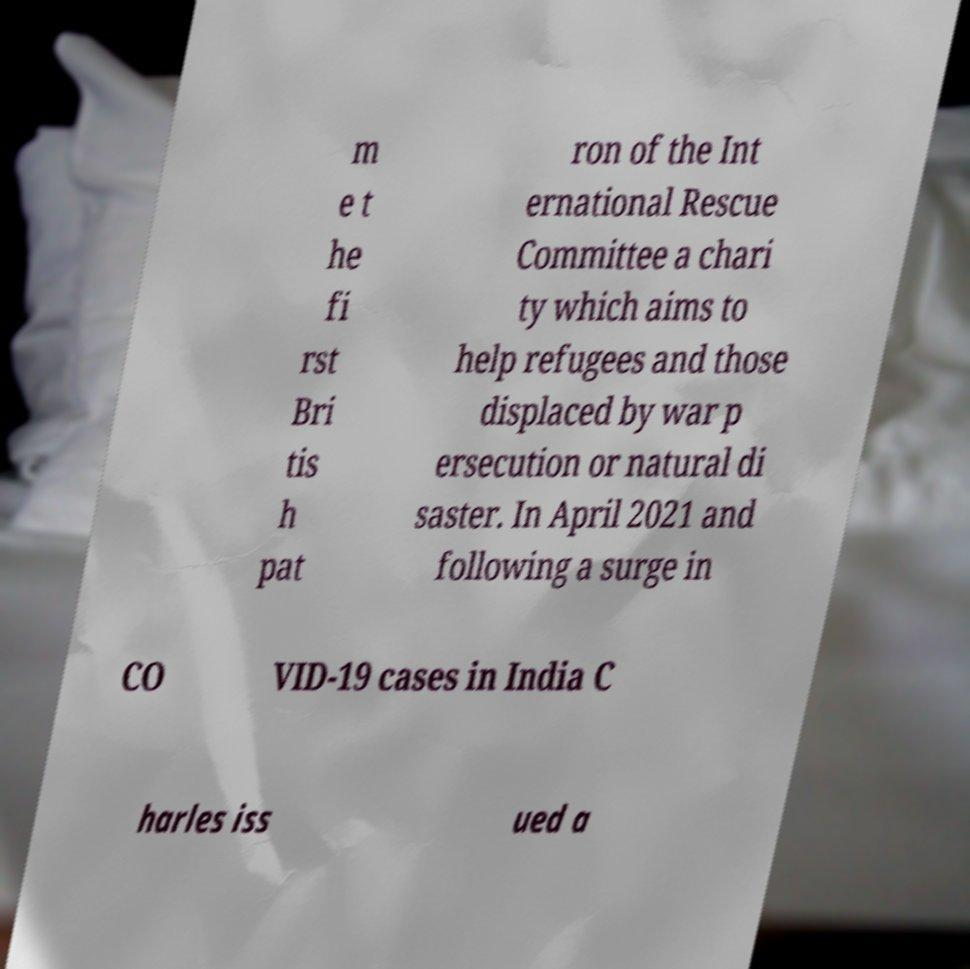There's text embedded in this image that I need extracted. Can you transcribe it verbatim? m e t he fi rst Bri tis h pat ron of the Int ernational Rescue Committee a chari ty which aims to help refugees and those displaced by war p ersecution or natural di saster. In April 2021 and following a surge in CO VID-19 cases in India C harles iss ued a 